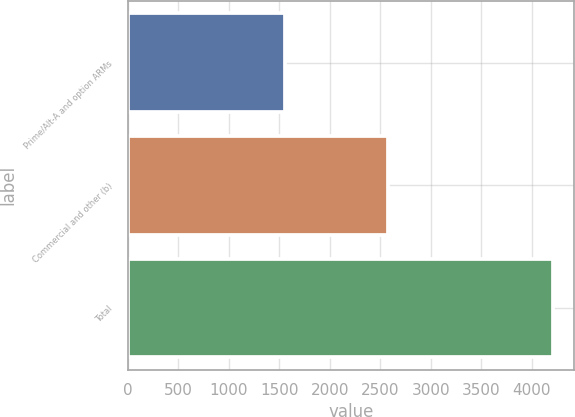<chart> <loc_0><loc_0><loc_500><loc_500><bar_chart><fcel>Prime/Alt-A and option ARMs<fcel>Commercial and other (b)<fcel>Total<nl><fcel>1560<fcel>2573<fcel>4209<nl></chart> 